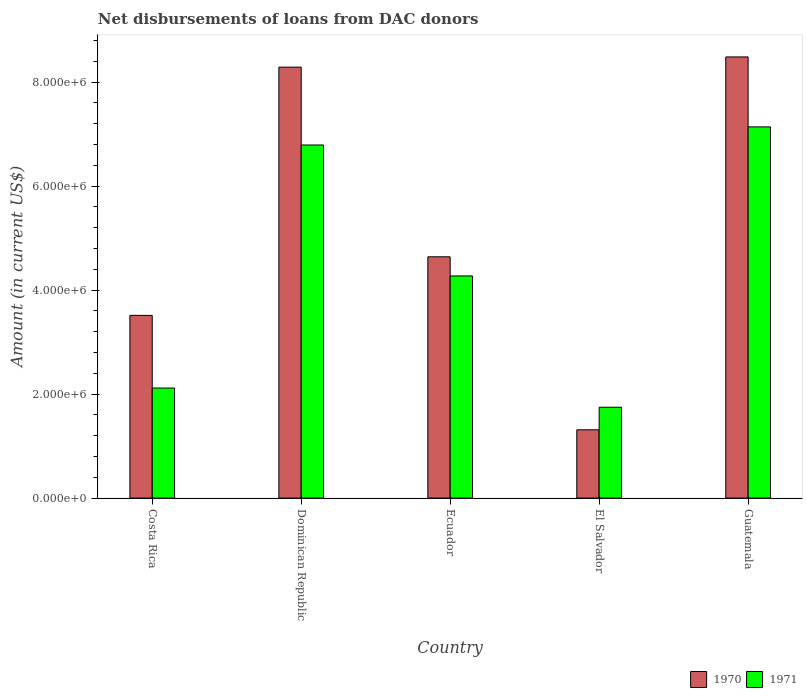How many different coloured bars are there?
Offer a very short reply. 2. How many groups of bars are there?
Provide a short and direct response. 5. Are the number of bars on each tick of the X-axis equal?
Provide a succinct answer. Yes. How many bars are there on the 4th tick from the right?
Offer a very short reply. 2. In how many cases, is the number of bars for a given country not equal to the number of legend labels?
Offer a very short reply. 0. What is the amount of loans disbursed in 1971 in Ecuador?
Your answer should be very brief. 4.27e+06. Across all countries, what is the maximum amount of loans disbursed in 1971?
Keep it short and to the point. 7.14e+06. Across all countries, what is the minimum amount of loans disbursed in 1971?
Offer a very short reply. 1.75e+06. In which country was the amount of loans disbursed in 1971 maximum?
Make the answer very short. Guatemala. In which country was the amount of loans disbursed in 1971 minimum?
Provide a short and direct response. El Salvador. What is the total amount of loans disbursed in 1971 in the graph?
Keep it short and to the point. 2.21e+07. What is the difference between the amount of loans disbursed in 1970 in Dominican Republic and that in El Salvador?
Offer a very short reply. 6.97e+06. What is the difference between the amount of loans disbursed in 1970 in Dominican Republic and the amount of loans disbursed in 1971 in Ecuador?
Your answer should be very brief. 4.02e+06. What is the average amount of loans disbursed in 1970 per country?
Offer a terse response. 5.25e+06. What is the difference between the amount of loans disbursed of/in 1971 and amount of loans disbursed of/in 1970 in Ecuador?
Your answer should be compact. -3.68e+05. What is the ratio of the amount of loans disbursed in 1970 in Ecuador to that in El Salvador?
Your answer should be very brief. 3.53. Is the difference between the amount of loans disbursed in 1971 in Dominican Republic and Guatemala greater than the difference between the amount of loans disbursed in 1970 in Dominican Republic and Guatemala?
Your answer should be very brief. No. What is the difference between the highest and the second highest amount of loans disbursed in 1970?
Your response must be concise. 3.84e+06. What is the difference between the highest and the lowest amount of loans disbursed in 1971?
Offer a very short reply. 5.39e+06. What does the 1st bar from the left in Ecuador represents?
Offer a very short reply. 1970. How many bars are there?
Ensure brevity in your answer.  10. What is the difference between two consecutive major ticks on the Y-axis?
Offer a very short reply. 2.00e+06. Does the graph contain any zero values?
Your answer should be compact. No. Does the graph contain grids?
Your answer should be very brief. No. How many legend labels are there?
Provide a short and direct response. 2. How are the legend labels stacked?
Offer a very short reply. Horizontal. What is the title of the graph?
Make the answer very short. Net disbursements of loans from DAC donors. What is the Amount (in current US$) of 1970 in Costa Rica?
Offer a terse response. 3.51e+06. What is the Amount (in current US$) in 1971 in Costa Rica?
Provide a succinct answer. 2.12e+06. What is the Amount (in current US$) of 1970 in Dominican Republic?
Offer a very short reply. 8.29e+06. What is the Amount (in current US$) in 1971 in Dominican Republic?
Your answer should be compact. 6.79e+06. What is the Amount (in current US$) of 1970 in Ecuador?
Offer a very short reply. 4.64e+06. What is the Amount (in current US$) of 1971 in Ecuador?
Provide a succinct answer. 4.27e+06. What is the Amount (in current US$) of 1970 in El Salvador?
Your answer should be very brief. 1.31e+06. What is the Amount (in current US$) of 1971 in El Salvador?
Give a very brief answer. 1.75e+06. What is the Amount (in current US$) in 1970 in Guatemala?
Offer a terse response. 8.48e+06. What is the Amount (in current US$) of 1971 in Guatemala?
Keep it short and to the point. 7.14e+06. Across all countries, what is the maximum Amount (in current US$) in 1970?
Offer a terse response. 8.48e+06. Across all countries, what is the maximum Amount (in current US$) of 1971?
Ensure brevity in your answer.  7.14e+06. Across all countries, what is the minimum Amount (in current US$) of 1970?
Provide a succinct answer. 1.31e+06. Across all countries, what is the minimum Amount (in current US$) of 1971?
Your answer should be compact. 1.75e+06. What is the total Amount (in current US$) of 1970 in the graph?
Provide a succinct answer. 2.62e+07. What is the total Amount (in current US$) of 1971 in the graph?
Keep it short and to the point. 2.21e+07. What is the difference between the Amount (in current US$) in 1970 in Costa Rica and that in Dominican Republic?
Provide a short and direct response. -4.77e+06. What is the difference between the Amount (in current US$) of 1971 in Costa Rica and that in Dominican Republic?
Ensure brevity in your answer.  -4.67e+06. What is the difference between the Amount (in current US$) in 1970 in Costa Rica and that in Ecuador?
Provide a short and direct response. -1.13e+06. What is the difference between the Amount (in current US$) of 1971 in Costa Rica and that in Ecuador?
Provide a short and direct response. -2.16e+06. What is the difference between the Amount (in current US$) in 1970 in Costa Rica and that in El Salvador?
Your answer should be compact. 2.20e+06. What is the difference between the Amount (in current US$) of 1971 in Costa Rica and that in El Salvador?
Provide a short and direct response. 3.69e+05. What is the difference between the Amount (in current US$) of 1970 in Costa Rica and that in Guatemala?
Keep it short and to the point. -4.97e+06. What is the difference between the Amount (in current US$) of 1971 in Costa Rica and that in Guatemala?
Keep it short and to the point. -5.02e+06. What is the difference between the Amount (in current US$) of 1970 in Dominican Republic and that in Ecuador?
Offer a very short reply. 3.65e+06. What is the difference between the Amount (in current US$) in 1971 in Dominican Republic and that in Ecuador?
Give a very brief answer. 2.52e+06. What is the difference between the Amount (in current US$) in 1970 in Dominican Republic and that in El Salvador?
Make the answer very short. 6.97e+06. What is the difference between the Amount (in current US$) in 1971 in Dominican Republic and that in El Salvador?
Make the answer very short. 5.04e+06. What is the difference between the Amount (in current US$) of 1970 in Dominican Republic and that in Guatemala?
Your answer should be compact. -1.96e+05. What is the difference between the Amount (in current US$) of 1971 in Dominican Republic and that in Guatemala?
Give a very brief answer. -3.48e+05. What is the difference between the Amount (in current US$) in 1970 in Ecuador and that in El Salvador?
Provide a short and direct response. 3.33e+06. What is the difference between the Amount (in current US$) of 1971 in Ecuador and that in El Salvador?
Your answer should be very brief. 2.52e+06. What is the difference between the Amount (in current US$) in 1970 in Ecuador and that in Guatemala?
Give a very brief answer. -3.84e+06. What is the difference between the Amount (in current US$) in 1971 in Ecuador and that in Guatemala?
Keep it short and to the point. -2.87e+06. What is the difference between the Amount (in current US$) in 1970 in El Salvador and that in Guatemala?
Your answer should be very brief. -7.17e+06. What is the difference between the Amount (in current US$) of 1971 in El Salvador and that in Guatemala?
Make the answer very short. -5.39e+06. What is the difference between the Amount (in current US$) of 1970 in Costa Rica and the Amount (in current US$) of 1971 in Dominican Republic?
Ensure brevity in your answer.  -3.28e+06. What is the difference between the Amount (in current US$) of 1970 in Costa Rica and the Amount (in current US$) of 1971 in Ecuador?
Your answer should be very brief. -7.58e+05. What is the difference between the Amount (in current US$) of 1970 in Costa Rica and the Amount (in current US$) of 1971 in El Salvador?
Make the answer very short. 1.77e+06. What is the difference between the Amount (in current US$) in 1970 in Costa Rica and the Amount (in current US$) in 1971 in Guatemala?
Offer a terse response. -3.62e+06. What is the difference between the Amount (in current US$) in 1970 in Dominican Republic and the Amount (in current US$) in 1971 in Ecuador?
Provide a succinct answer. 4.02e+06. What is the difference between the Amount (in current US$) of 1970 in Dominican Republic and the Amount (in current US$) of 1971 in El Salvador?
Keep it short and to the point. 6.54e+06. What is the difference between the Amount (in current US$) in 1970 in Dominican Republic and the Amount (in current US$) in 1971 in Guatemala?
Your answer should be compact. 1.15e+06. What is the difference between the Amount (in current US$) in 1970 in Ecuador and the Amount (in current US$) in 1971 in El Salvador?
Provide a short and direct response. 2.89e+06. What is the difference between the Amount (in current US$) in 1970 in Ecuador and the Amount (in current US$) in 1971 in Guatemala?
Keep it short and to the point. -2.50e+06. What is the difference between the Amount (in current US$) in 1970 in El Salvador and the Amount (in current US$) in 1971 in Guatemala?
Your answer should be very brief. -5.82e+06. What is the average Amount (in current US$) of 1970 per country?
Make the answer very short. 5.25e+06. What is the average Amount (in current US$) of 1971 per country?
Give a very brief answer. 4.41e+06. What is the difference between the Amount (in current US$) of 1970 and Amount (in current US$) of 1971 in Costa Rica?
Give a very brief answer. 1.40e+06. What is the difference between the Amount (in current US$) in 1970 and Amount (in current US$) in 1971 in Dominican Republic?
Ensure brevity in your answer.  1.50e+06. What is the difference between the Amount (in current US$) in 1970 and Amount (in current US$) in 1971 in Ecuador?
Give a very brief answer. 3.68e+05. What is the difference between the Amount (in current US$) of 1970 and Amount (in current US$) of 1971 in El Salvador?
Provide a succinct answer. -4.34e+05. What is the difference between the Amount (in current US$) of 1970 and Amount (in current US$) of 1971 in Guatemala?
Offer a very short reply. 1.34e+06. What is the ratio of the Amount (in current US$) in 1970 in Costa Rica to that in Dominican Republic?
Your answer should be compact. 0.42. What is the ratio of the Amount (in current US$) in 1971 in Costa Rica to that in Dominican Republic?
Your answer should be compact. 0.31. What is the ratio of the Amount (in current US$) in 1970 in Costa Rica to that in Ecuador?
Provide a succinct answer. 0.76. What is the ratio of the Amount (in current US$) in 1971 in Costa Rica to that in Ecuador?
Provide a succinct answer. 0.5. What is the ratio of the Amount (in current US$) of 1970 in Costa Rica to that in El Salvador?
Offer a terse response. 2.68. What is the ratio of the Amount (in current US$) of 1971 in Costa Rica to that in El Salvador?
Ensure brevity in your answer.  1.21. What is the ratio of the Amount (in current US$) in 1970 in Costa Rica to that in Guatemala?
Provide a succinct answer. 0.41. What is the ratio of the Amount (in current US$) in 1971 in Costa Rica to that in Guatemala?
Your answer should be very brief. 0.3. What is the ratio of the Amount (in current US$) of 1970 in Dominican Republic to that in Ecuador?
Your answer should be compact. 1.79. What is the ratio of the Amount (in current US$) of 1971 in Dominican Republic to that in Ecuador?
Keep it short and to the point. 1.59. What is the ratio of the Amount (in current US$) of 1970 in Dominican Republic to that in El Salvador?
Provide a short and direct response. 6.31. What is the ratio of the Amount (in current US$) of 1971 in Dominican Republic to that in El Salvador?
Offer a terse response. 3.89. What is the ratio of the Amount (in current US$) of 1970 in Dominican Republic to that in Guatemala?
Provide a succinct answer. 0.98. What is the ratio of the Amount (in current US$) of 1971 in Dominican Republic to that in Guatemala?
Provide a short and direct response. 0.95. What is the ratio of the Amount (in current US$) in 1970 in Ecuador to that in El Salvador?
Give a very brief answer. 3.53. What is the ratio of the Amount (in current US$) of 1971 in Ecuador to that in El Salvador?
Your response must be concise. 2.44. What is the ratio of the Amount (in current US$) of 1970 in Ecuador to that in Guatemala?
Offer a very short reply. 0.55. What is the ratio of the Amount (in current US$) in 1971 in Ecuador to that in Guatemala?
Your answer should be very brief. 0.6. What is the ratio of the Amount (in current US$) in 1970 in El Salvador to that in Guatemala?
Your response must be concise. 0.15. What is the ratio of the Amount (in current US$) in 1971 in El Salvador to that in Guatemala?
Provide a short and direct response. 0.24. What is the difference between the highest and the second highest Amount (in current US$) in 1970?
Your answer should be compact. 1.96e+05. What is the difference between the highest and the second highest Amount (in current US$) in 1971?
Give a very brief answer. 3.48e+05. What is the difference between the highest and the lowest Amount (in current US$) in 1970?
Make the answer very short. 7.17e+06. What is the difference between the highest and the lowest Amount (in current US$) of 1971?
Make the answer very short. 5.39e+06. 